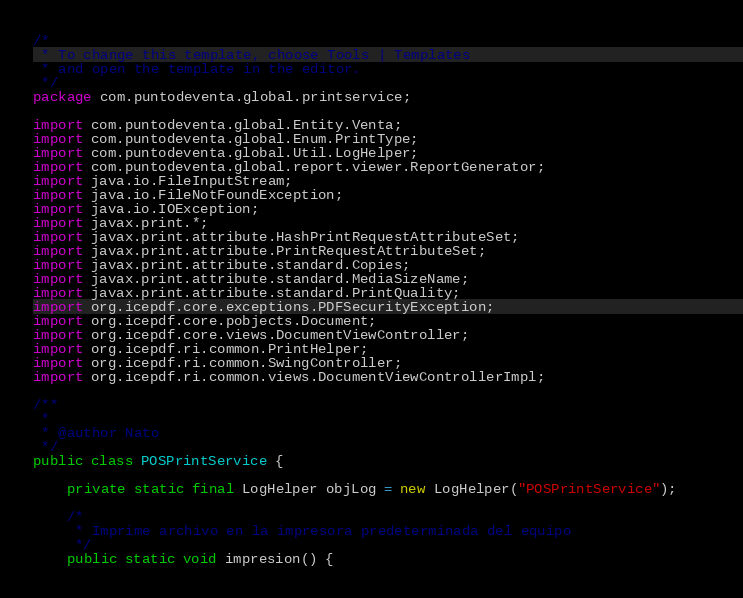<code> <loc_0><loc_0><loc_500><loc_500><_Java_>/*
 * To change this template, choose Tools | Templates
 * and open the template in the editor.
 */
package com.puntodeventa.global.printservice;

import com.puntodeventa.global.Entity.Venta;
import com.puntodeventa.global.Enum.PrintType;
import com.puntodeventa.global.Util.LogHelper;
import com.puntodeventa.global.report.viewer.ReportGenerator;
import java.io.FileInputStream;
import java.io.FileNotFoundException;
import java.io.IOException;
import javax.print.*;
import javax.print.attribute.HashPrintRequestAttributeSet;
import javax.print.attribute.PrintRequestAttributeSet;
import javax.print.attribute.standard.Copies;
import javax.print.attribute.standard.MediaSizeName;
import javax.print.attribute.standard.PrintQuality;
import org.icepdf.core.exceptions.PDFSecurityException;
import org.icepdf.core.pobjects.Document;
import org.icepdf.core.views.DocumentViewController;
import org.icepdf.ri.common.PrintHelper;
import org.icepdf.ri.common.SwingController;
import org.icepdf.ri.common.views.DocumentViewControllerImpl;

/**
 *
 * @author Nato
 */
public class POSPrintService {
    
    private static final LogHelper objLog = new LogHelper("POSPrintService");    

    /*
     * Imprime archivo en la impresora predeterminada del equipo
     */
    public static void impresion() {</code> 